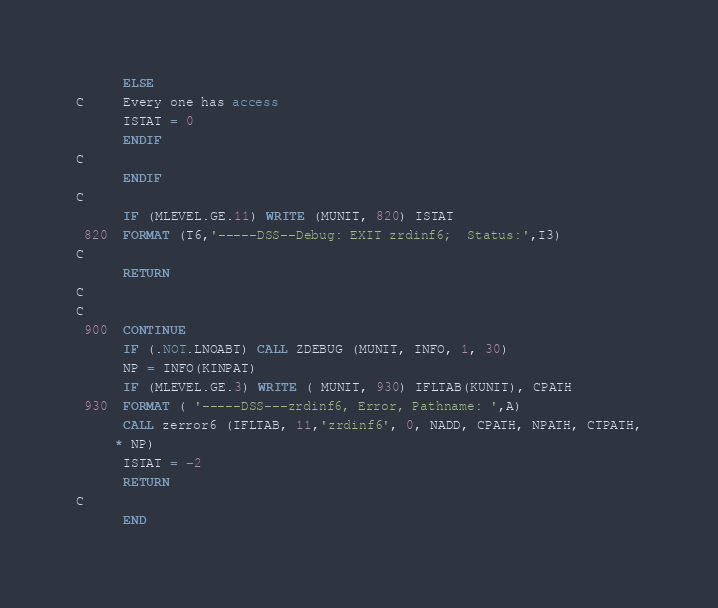Convert code to text. <code><loc_0><loc_0><loc_500><loc_500><_FORTRAN_>      ELSE
C     Every one has access
      ISTAT = 0
      ENDIF
C
      ENDIF
C
      IF (MLEVEL.GE.11) WRITE (MUNIT, 820) ISTAT
 820  FORMAT (T6,'-----DSS--Debug: EXIT zrdinf6;  Status:',I3)
C
      RETURN
C
C
 900  CONTINUE
      IF (.NOT.LNOABT) CALL ZDEBUG (MUNIT, INFO, 1, 30)
      NP = INFO(KINPAT)
      IF (MLEVEL.GE.3) WRITE ( MUNIT, 930) IFLTAB(KUNIT), CPATH
 930  FORMAT ( '-----DSS---zrdinf6, Error, Pathname: ',A)
      CALL zerror6 (IFLTAB, 11,'zrdinf6', 0, NADD, CPATH, NPATH, CTPATH,
     * NP)
      ISTAT = -2
      RETURN
C
      END

</code> 